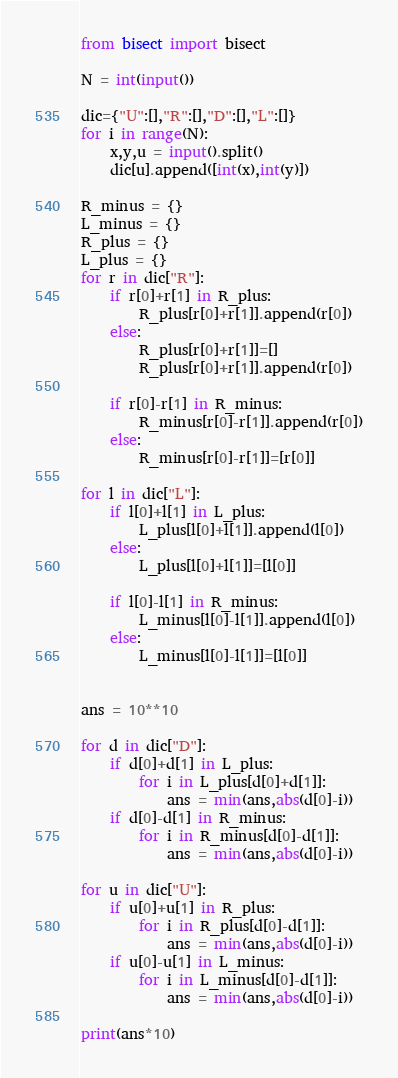<code> <loc_0><loc_0><loc_500><loc_500><_Python_>from bisect import bisect

N = int(input())

dic={"U":[],"R":[],"D":[],"L":[]}
for i in range(N):
    x,y,u = input().split()
    dic[u].append([int(x),int(y)])

R_minus = {}
L_minus = {}
R_plus = {}
L_plus = {}
for r in dic["R"]:
    if r[0]+r[1] in R_plus:
        R_plus[r[0]+r[1]].append(r[0])
    else:
        R_plus[r[0]+r[1]]=[]
        R_plus[r[0]+r[1]].append(r[0])

    if r[0]-r[1] in R_minus:
        R_minus[r[0]-r[1]].append(r[0])
    else:
        R_minus[r[0]-r[1]]=[r[0]]

for l in dic["L"]:
    if l[0]+l[1] in L_plus:
        L_plus[l[0]+l[1]].append(l[0])
    else:
        L_plus[l[0]+l[1]]=[l[0]]

    if l[0]-l[1] in R_minus:
        L_minus[l[0]-l[1]].append(l[0])
    else:
        L_minus[l[0]-l[1]]=[l[0]]


ans = 10**10

for d in dic["D"]:
    if d[0]+d[1] in L_plus:
        for i in L_plus[d[0]+d[1]]:
            ans = min(ans,abs(d[0]-i))
    if d[0]-d[1] in R_minus:
        for i in R_minus[d[0]-d[1]]:
            ans = min(ans,abs(d[0]-i))

for u in dic["U"]:
    if u[0]+u[1] in R_plus:
        for i in R_plus[d[0]-d[1]]:
            ans = min(ans,abs(d[0]-i))
    if u[0]-u[1] in L_minus:
        for i in L_minus[d[0]-d[1]]:
            ans = min(ans,abs(d[0]-i))

print(ans*10)</code> 